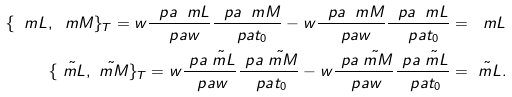Convert formula to latex. <formula><loc_0><loc_0><loc_500><loc_500>\{ \ m L , \ m M \} _ { T } = w \frac { \ p a \ m L } { \ p a w } \frac { \ p a \ m M } { \ p a t _ { 0 } } - w \frac { \ p a \ m M } { \ p a w } \frac { \ p a \ m L } { \ p a t _ { 0 } } = \ m L \\ \{ \tilde { \ m L } , \tilde { \ m M } \} _ { T } = w \frac { \ p a \tilde { \ m L } } { \ p a w } \frac { \ p a \tilde { \ m M } } { \ p a t _ { 0 } } - w \frac { \ p a \tilde { \ m M } } { \ p a w } \frac { \ p a \tilde { \ m L } } { \ p a t _ { 0 } } = \tilde { \ m L } .</formula> 